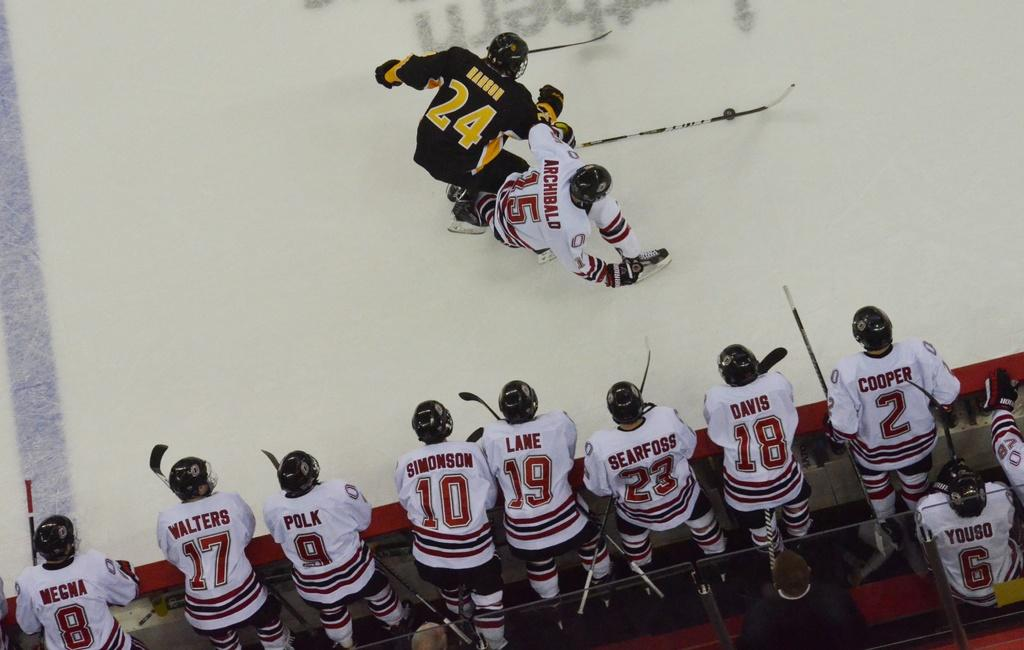What are the persons wearing in the image? The persons are wearing white color T-shirts in the image. What are the persons holding in the image? The persons are holding sticks in the image. What is located beside the persons in the image? There is a wall beside the persons in the image. What activity is taking place at the top of the image? Two persons are playing on a white color court at the top of the image. What type of veil can be seen covering the court in the image? There is no veil present in the image; the court is visible and not covered. What type of flesh is visible on the persons in the image? The image does not show any flesh, as the persons are wearing white color T-shirts that cover their bodies. 